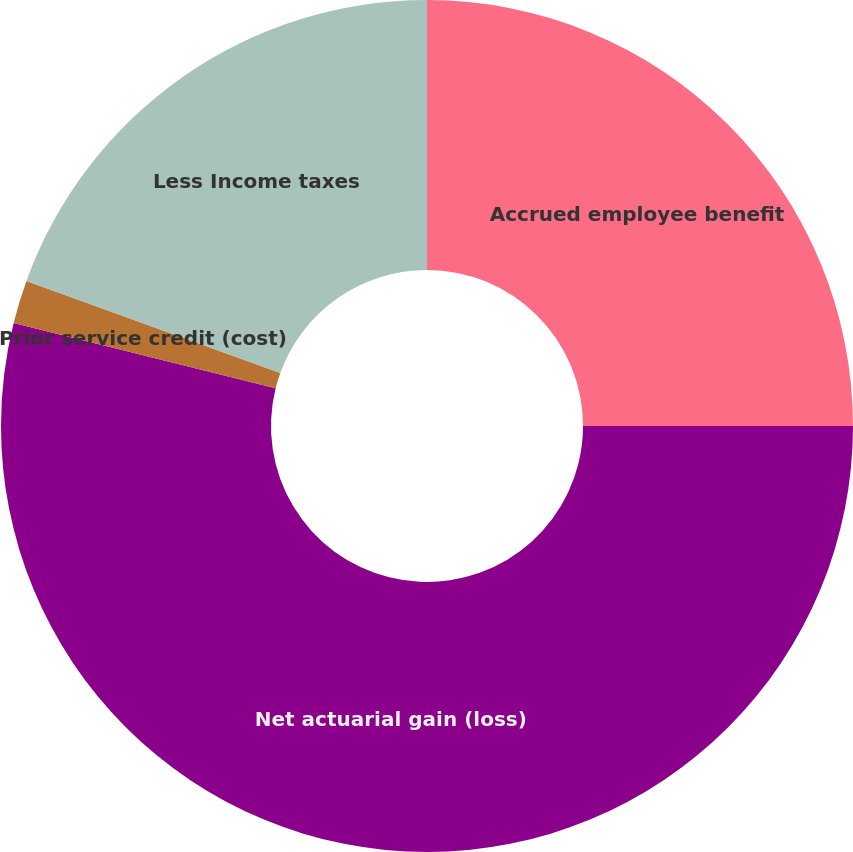Convert chart to OTSL. <chart><loc_0><loc_0><loc_500><loc_500><pie_chart><fcel>Accrued employee benefit<fcel>Net actuarial gain (loss)<fcel>Prior service credit (cost)<fcel>Less Income taxes<nl><fcel>25.0%<fcel>53.89%<fcel>1.64%<fcel>19.47%<nl></chart> 